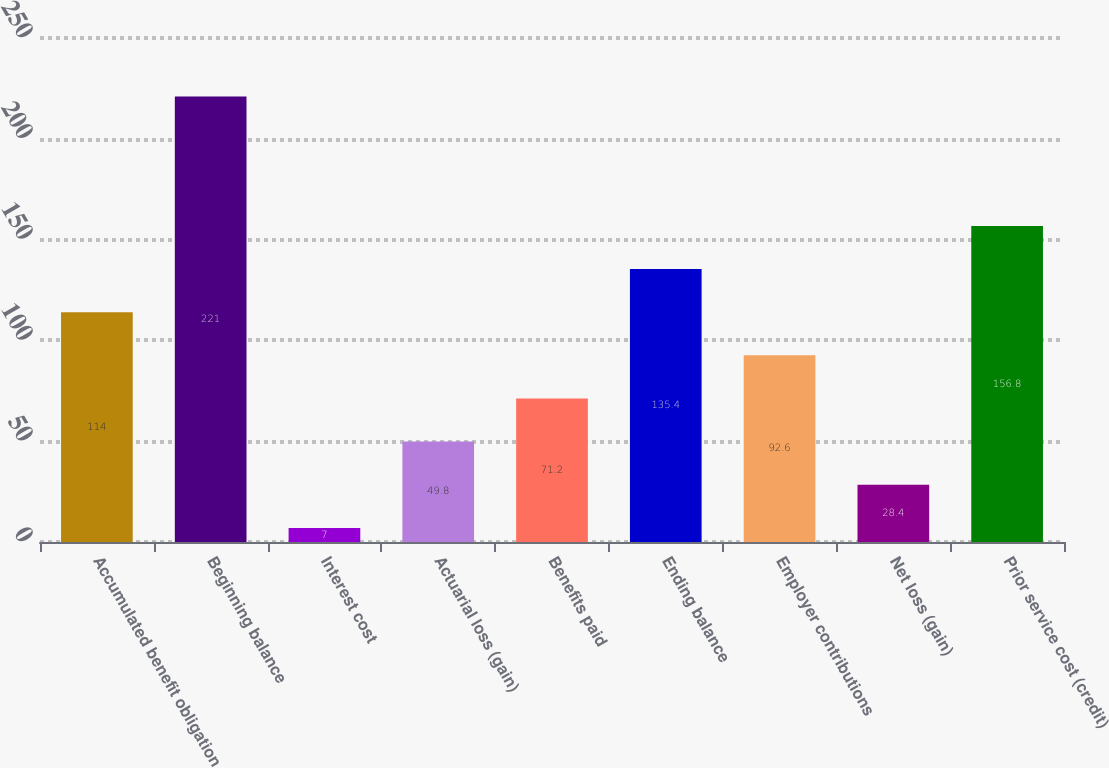Convert chart to OTSL. <chart><loc_0><loc_0><loc_500><loc_500><bar_chart><fcel>Accumulated benefit obligation<fcel>Beginning balance<fcel>Interest cost<fcel>Actuarial loss (gain)<fcel>Benefits paid<fcel>Ending balance<fcel>Employer contributions<fcel>Net loss (gain)<fcel>Prior service cost (credit)<nl><fcel>114<fcel>221<fcel>7<fcel>49.8<fcel>71.2<fcel>135.4<fcel>92.6<fcel>28.4<fcel>156.8<nl></chart> 